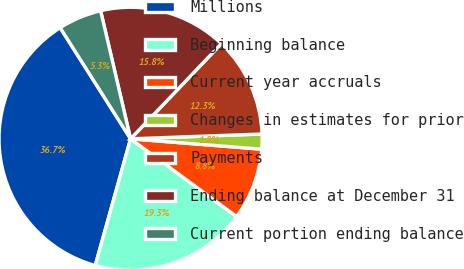Convert chart to OTSL. <chart><loc_0><loc_0><loc_500><loc_500><pie_chart><fcel>Millions<fcel>Beginning balance<fcel>Current year accruals<fcel>Changes in estimates for prior<fcel>Payments<fcel>Ending balance at December 31<fcel>Current portion ending balance<nl><fcel>36.68%<fcel>19.26%<fcel>8.81%<fcel>1.84%<fcel>12.29%<fcel>15.78%<fcel>5.33%<nl></chart> 